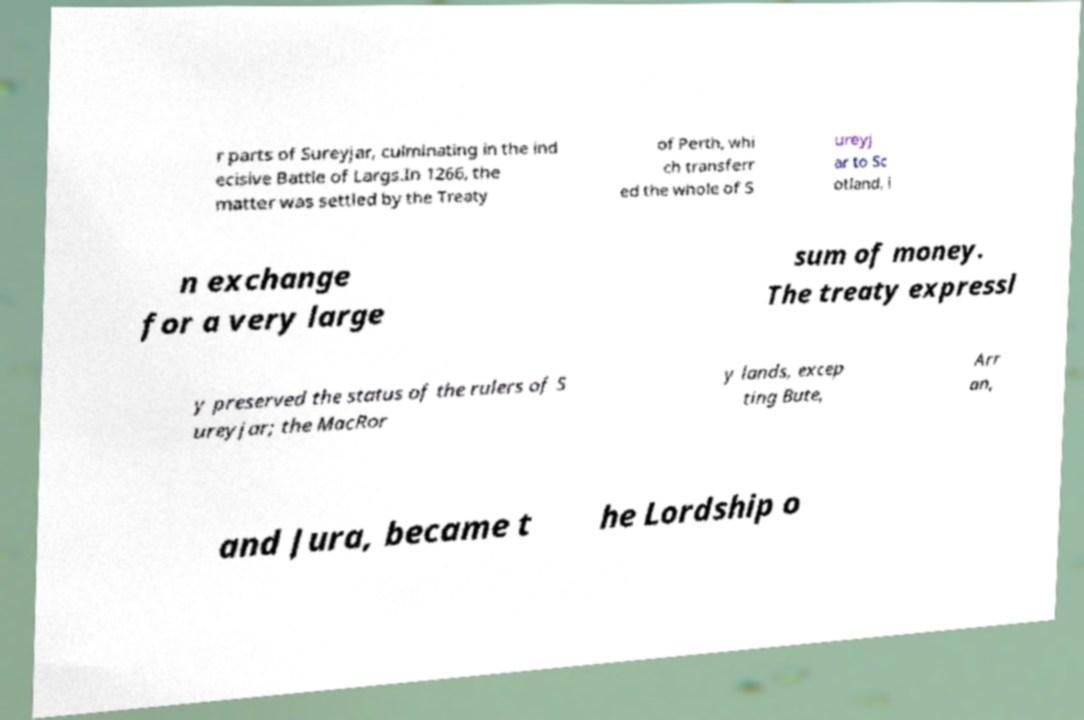Can you accurately transcribe the text from the provided image for me? r parts of Sureyjar, culminating in the ind ecisive Battle of Largs.In 1266, the matter was settled by the Treaty of Perth, whi ch transferr ed the whole of S ureyj ar to Sc otland, i n exchange for a very large sum of money. The treaty expressl y preserved the status of the rulers of S ureyjar; the MacRor y lands, excep ting Bute, Arr an, and Jura, became t he Lordship o 